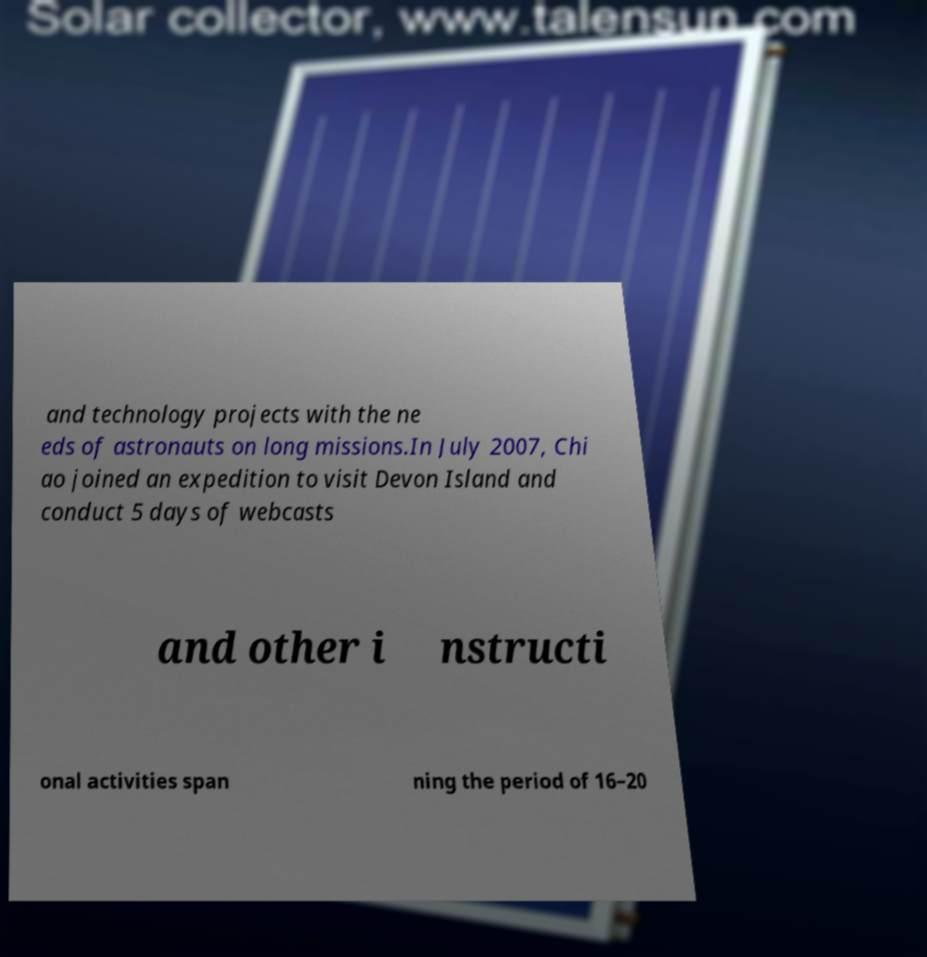I need the written content from this picture converted into text. Can you do that? and technology projects with the ne eds of astronauts on long missions.In July 2007, Chi ao joined an expedition to visit Devon Island and conduct 5 days of webcasts and other i nstructi onal activities span ning the period of 16–20 